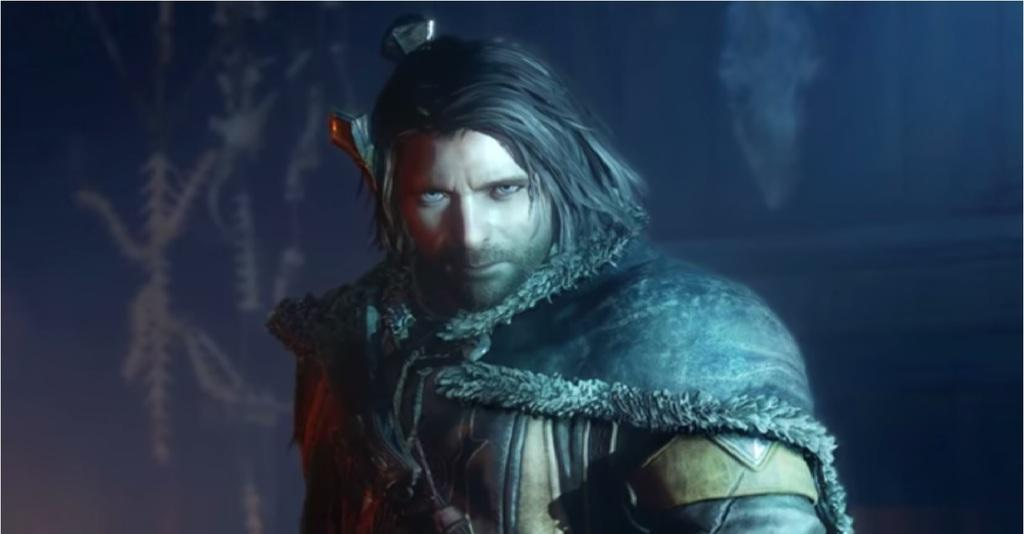What type of image is being described? The image is animated. Who or what can be seen in the image? There is a man in the image. What is visible in the background of the image? There is a wall in the background of the image. How many ants can be seen crawling on the wall in the image? There are no ants present in the image; it only features a man and a wall in the background. 